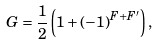<formula> <loc_0><loc_0><loc_500><loc_500>G = \frac { 1 } { 2 } \left ( 1 + ( - 1 ) ^ { F + F ^ { \prime } } \right ) ,</formula> 